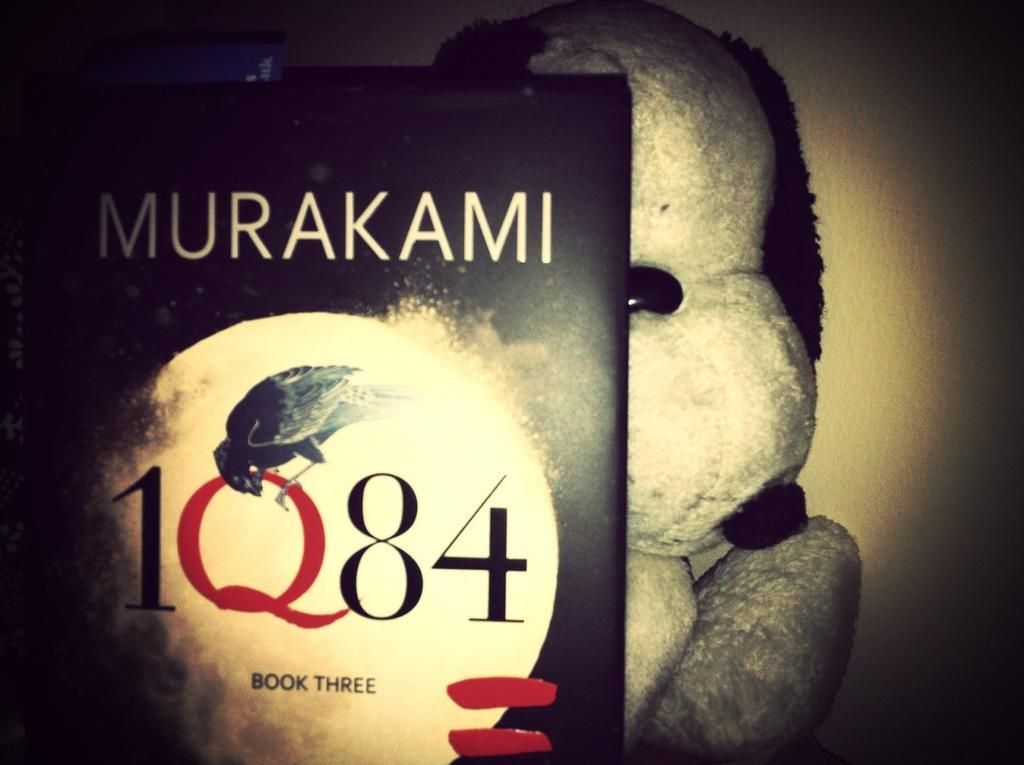<image>
Render a clear and concise summary of the photo. book three of 1Q84 with a black cover 